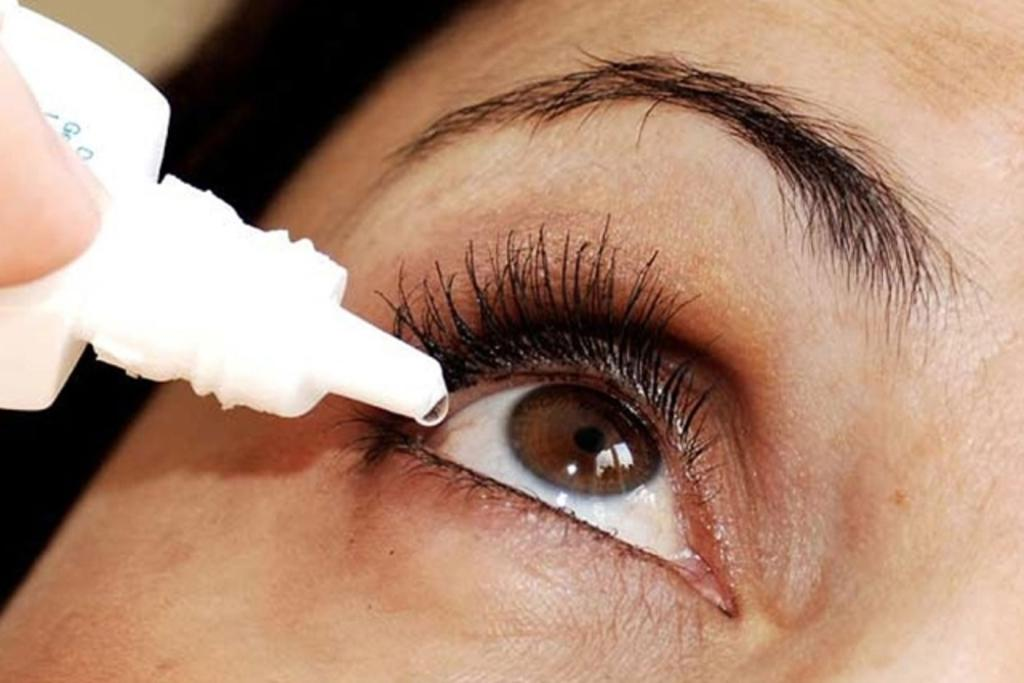What can be seen in the image? There is a person in the image. What is the person holding in the image? The person is holding a white-colored bottle. Can you describe the person's face in the image? The person's face is visible in the image. What type of underwear is the person wearing in the image? There is no information about the person's underwear in the image, so it cannot be determined. 